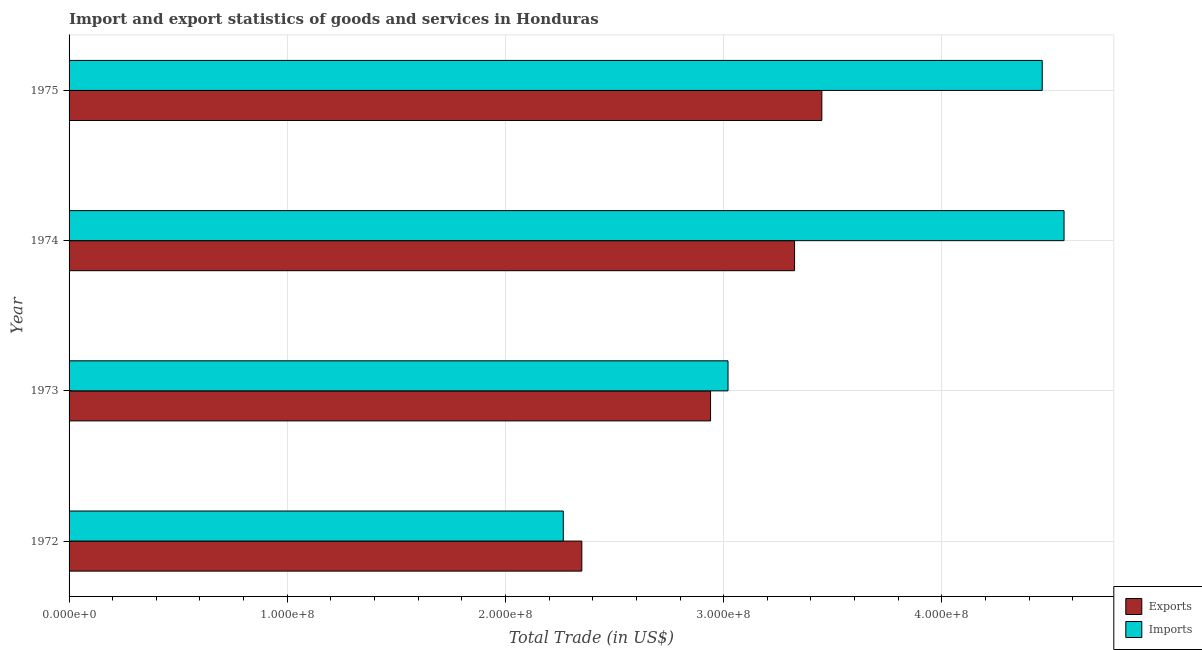How many different coloured bars are there?
Your answer should be very brief. 2. How many bars are there on the 1st tick from the bottom?
Your response must be concise. 2. What is the label of the 2nd group of bars from the top?
Give a very brief answer. 1974. What is the imports of goods and services in 1972?
Give a very brief answer. 2.26e+08. Across all years, what is the maximum imports of goods and services?
Keep it short and to the point. 4.56e+08. Across all years, what is the minimum export of goods and services?
Provide a succinct answer. 2.35e+08. In which year was the imports of goods and services maximum?
Your answer should be very brief. 1974. In which year was the imports of goods and services minimum?
Your response must be concise. 1972. What is the total imports of goods and services in the graph?
Your response must be concise. 1.43e+09. What is the difference between the export of goods and services in 1974 and that in 1975?
Ensure brevity in your answer.  -1.25e+07. What is the difference between the export of goods and services in 1975 and the imports of goods and services in 1973?
Give a very brief answer. 4.30e+07. What is the average export of goods and services per year?
Keep it short and to the point. 3.02e+08. In the year 1975, what is the difference between the imports of goods and services and export of goods and services?
Offer a terse response. 1.01e+08. In how many years, is the export of goods and services greater than 220000000 US$?
Provide a short and direct response. 4. What is the ratio of the export of goods and services in 1974 to that in 1975?
Your answer should be compact. 0.96. What is the difference between the highest and the second highest imports of goods and services?
Ensure brevity in your answer.  1.00e+07. What is the difference between the highest and the lowest imports of goods and services?
Ensure brevity in your answer.  2.30e+08. Is the sum of the imports of goods and services in 1973 and 1974 greater than the maximum export of goods and services across all years?
Make the answer very short. Yes. What does the 1st bar from the top in 1973 represents?
Your answer should be compact. Imports. What does the 1st bar from the bottom in 1972 represents?
Offer a very short reply. Exports. How many bars are there?
Your answer should be very brief. 8. Are all the bars in the graph horizontal?
Make the answer very short. Yes. What is the difference between two consecutive major ticks on the X-axis?
Give a very brief answer. 1.00e+08. Are the values on the major ticks of X-axis written in scientific E-notation?
Keep it short and to the point. Yes. Where does the legend appear in the graph?
Ensure brevity in your answer.  Bottom right. What is the title of the graph?
Your answer should be compact. Import and export statistics of goods and services in Honduras. What is the label or title of the X-axis?
Ensure brevity in your answer.  Total Trade (in US$). What is the label or title of the Y-axis?
Your response must be concise. Year. What is the Total Trade (in US$) of Exports in 1972?
Keep it short and to the point. 2.35e+08. What is the Total Trade (in US$) of Imports in 1972?
Offer a very short reply. 2.26e+08. What is the Total Trade (in US$) in Exports in 1973?
Your answer should be compact. 2.94e+08. What is the Total Trade (in US$) in Imports in 1973?
Keep it short and to the point. 3.02e+08. What is the Total Trade (in US$) of Exports in 1974?
Keep it short and to the point. 3.32e+08. What is the Total Trade (in US$) in Imports in 1974?
Ensure brevity in your answer.  4.56e+08. What is the Total Trade (in US$) of Exports in 1975?
Ensure brevity in your answer.  3.45e+08. What is the Total Trade (in US$) of Imports in 1975?
Give a very brief answer. 4.46e+08. Across all years, what is the maximum Total Trade (in US$) of Exports?
Make the answer very short. 3.45e+08. Across all years, what is the maximum Total Trade (in US$) of Imports?
Ensure brevity in your answer.  4.56e+08. Across all years, what is the minimum Total Trade (in US$) of Exports?
Give a very brief answer. 2.35e+08. Across all years, what is the minimum Total Trade (in US$) of Imports?
Your response must be concise. 2.26e+08. What is the total Total Trade (in US$) of Exports in the graph?
Ensure brevity in your answer.  1.21e+09. What is the total Total Trade (in US$) in Imports in the graph?
Ensure brevity in your answer.  1.43e+09. What is the difference between the Total Trade (in US$) in Exports in 1972 and that in 1973?
Provide a short and direct response. -5.90e+07. What is the difference between the Total Trade (in US$) in Imports in 1972 and that in 1973?
Give a very brief answer. -7.55e+07. What is the difference between the Total Trade (in US$) in Exports in 1972 and that in 1974?
Give a very brief answer. -9.75e+07. What is the difference between the Total Trade (in US$) of Imports in 1972 and that in 1974?
Ensure brevity in your answer.  -2.30e+08. What is the difference between the Total Trade (in US$) of Exports in 1972 and that in 1975?
Your response must be concise. -1.10e+08. What is the difference between the Total Trade (in US$) of Imports in 1972 and that in 1975?
Your answer should be compact. -2.20e+08. What is the difference between the Total Trade (in US$) of Exports in 1973 and that in 1974?
Ensure brevity in your answer.  -3.85e+07. What is the difference between the Total Trade (in US$) of Imports in 1973 and that in 1974?
Provide a succinct answer. -1.54e+08. What is the difference between the Total Trade (in US$) in Exports in 1973 and that in 1975?
Ensure brevity in your answer.  -5.10e+07. What is the difference between the Total Trade (in US$) of Imports in 1973 and that in 1975?
Make the answer very short. -1.44e+08. What is the difference between the Total Trade (in US$) in Exports in 1974 and that in 1975?
Offer a terse response. -1.25e+07. What is the difference between the Total Trade (in US$) of Exports in 1972 and the Total Trade (in US$) of Imports in 1973?
Your answer should be compact. -6.70e+07. What is the difference between the Total Trade (in US$) in Exports in 1972 and the Total Trade (in US$) in Imports in 1974?
Give a very brief answer. -2.21e+08. What is the difference between the Total Trade (in US$) of Exports in 1972 and the Total Trade (in US$) of Imports in 1975?
Offer a very short reply. -2.11e+08. What is the difference between the Total Trade (in US$) of Exports in 1973 and the Total Trade (in US$) of Imports in 1974?
Offer a very short reply. -1.62e+08. What is the difference between the Total Trade (in US$) in Exports in 1973 and the Total Trade (in US$) in Imports in 1975?
Your answer should be very brief. -1.52e+08. What is the difference between the Total Trade (in US$) in Exports in 1974 and the Total Trade (in US$) in Imports in 1975?
Keep it short and to the point. -1.14e+08. What is the average Total Trade (in US$) of Exports per year?
Provide a succinct answer. 3.02e+08. What is the average Total Trade (in US$) of Imports per year?
Make the answer very short. 3.58e+08. In the year 1972, what is the difference between the Total Trade (in US$) in Exports and Total Trade (in US$) in Imports?
Keep it short and to the point. 8.50e+06. In the year 1973, what is the difference between the Total Trade (in US$) in Exports and Total Trade (in US$) in Imports?
Offer a terse response. -8.00e+06. In the year 1974, what is the difference between the Total Trade (in US$) in Exports and Total Trade (in US$) in Imports?
Provide a short and direct response. -1.24e+08. In the year 1975, what is the difference between the Total Trade (in US$) in Exports and Total Trade (in US$) in Imports?
Make the answer very short. -1.01e+08. What is the ratio of the Total Trade (in US$) in Exports in 1972 to that in 1973?
Your response must be concise. 0.8. What is the ratio of the Total Trade (in US$) in Imports in 1972 to that in 1973?
Provide a succinct answer. 0.75. What is the ratio of the Total Trade (in US$) of Exports in 1972 to that in 1974?
Keep it short and to the point. 0.71. What is the ratio of the Total Trade (in US$) of Imports in 1972 to that in 1974?
Provide a succinct answer. 0.5. What is the ratio of the Total Trade (in US$) of Exports in 1972 to that in 1975?
Ensure brevity in your answer.  0.68. What is the ratio of the Total Trade (in US$) of Imports in 1972 to that in 1975?
Give a very brief answer. 0.51. What is the ratio of the Total Trade (in US$) in Exports in 1973 to that in 1974?
Make the answer very short. 0.88. What is the ratio of the Total Trade (in US$) of Imports in 1973 to that in 1974?
Offer a very short reply. 0.66. What is the ratio of the Total Trade (in US$) in Exports in 1973 to that in 1975?
Provide a short and direct response. 0.85. What is the ratio of the Total Trade (in US$) of Imports in 1973 to that in 1975?
Make the answer very short. 0.68. What is the ratio of the Total Trade (in US$) of Exports in 1974 to that in 1975?
Ensure brevity in your answer.  0.96. What is the ratio of the Total Trade (in US$) in Imports in 1974 to that in 1975?
Offer a terse response. 1.02. What is the difference between the highest and the second highest Total Trade (in US$) of Exports?
Provide a succinct answer. 1.25e+07. What is the difference between the highest and the second highest Total Trade (in US$) in Imports?
Provide a short and direct response. 1.00e+07. What is the difference between the highest and the lowest Total Trade (in US$) in Exports?
Ensure brevity in your answer.  1.10e+08. What is the difference between the highest and the lowest Total Trade (in US$) of Imports?
Your answer should be compact. 2.30e+08. 